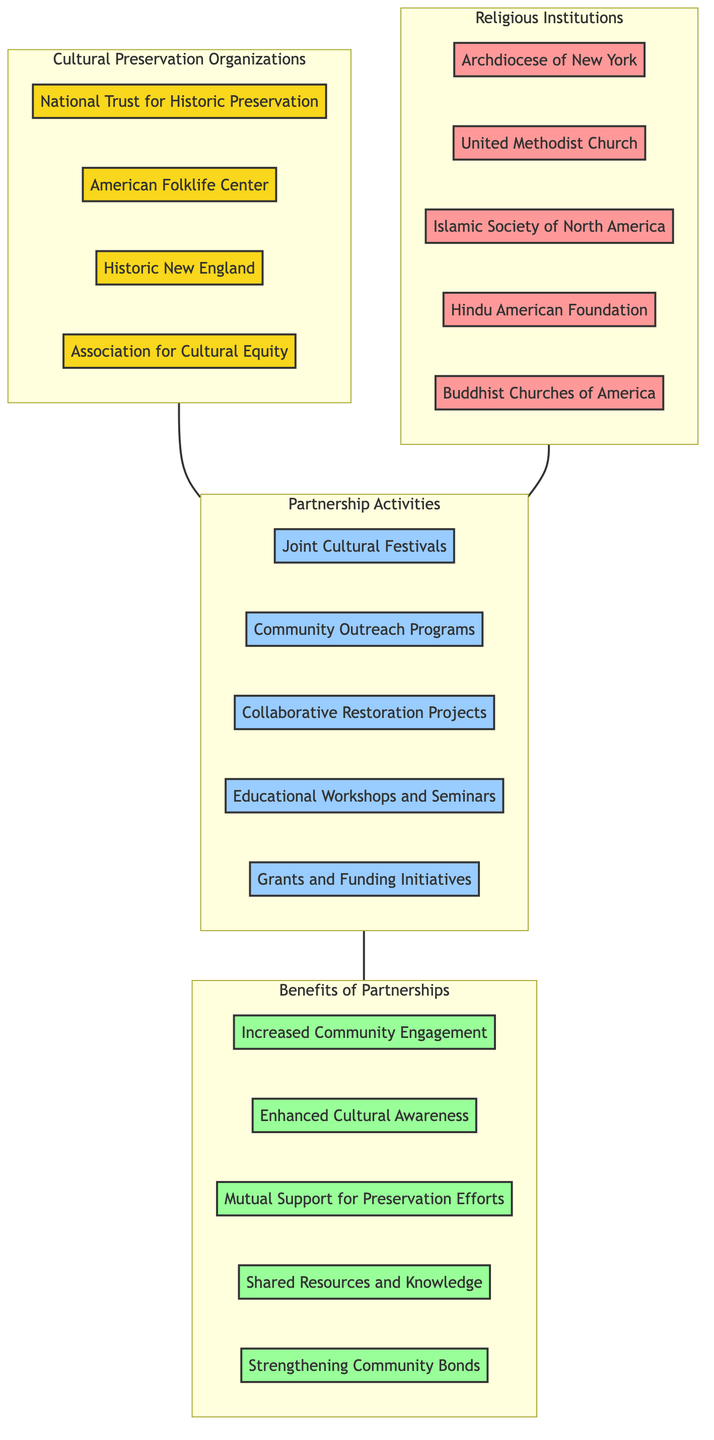What are the total number of Cultural Preservation Organizations? There are four nodes listed under Cultural Preservation Organizations: National Trust for Historic Preservation, American Folklife Center, Historic New England, and Association for Cultural Equity. Thus, the total is 4.
Answer: 4 Which Religious Institution is included in the diagram? The Religious Institutions listed are Archdiocese of New York, United Methodist Church, Islamic Society of North America, Hindu American Foundation, and Buddhist Churches of America. One example is Archdiocese of New York.
Answer: Archdiocese of New York Name one Partnership Activity. There are five Partnership Activities shown: Joint Cultural Festivals, Community Outreach Programs, Collaborative Restoration Projects, Educational Workshops and Seminars, and Grants and Funding Initiatives. One example is Joint Cultural Festivals.
Answer: Joint Cultural Festivals How many benefits of partnerships are listed? The diagram contains five benefits of partnerships, which include Increased Community Engagement, Enhanced Cultural Awareness, Mutual Support for Preservation Efforts, Shared Resources and Knowledge, and Strengthening Community Bonds. Therefore, the number is 5.
Answer: 5 What is a benefit that results from the partnerships between Cultural Preservation Organizations and Religious Institutions? One of the benefits listed is Increased Community Engagement. This benefit reflects the positive outcome of the partnership activities described in the diagram.
Answer: Increased Community Engagement Which type of nodes connect Cultural Preservation Organizations with Partnership Activities? The nodes connecting them are partnership activities such as Joint Cultural Festivals, Community Outreach Programs, etc. The relationships are depicted by edges leading from the Cultural Preservation Organizations to the Partnership Activities.
Answer: Partnership Activities How many edges connect Religious Institutions to Partnership Activities? Since there are five Religious Institutions and each can be connected to the five Partnership Activities, it could potentially indicate multiple edges, but in the diagram, each Religious Institution connects to the Partnership Activities collectively. Therefore, there are five relationships outward.
Answer: 5 What can be inferred about the relationship between benefits and partnership activities? The edges connect the Partnership Activities to the Benefits of Partnerships, indicating that various activities lead to multiple benefits. Each partnership activity can lead to one or more of the benefits listed.
Answer: Mutual connection 